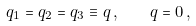Convert formula to latex. <formula><loc_0><loc_0><loc_500><loc_500>q _ { 1 } = q _ { 2 } = q _ { 3 } \equiv q \, , \quad q = 0 \, ,</formula> 